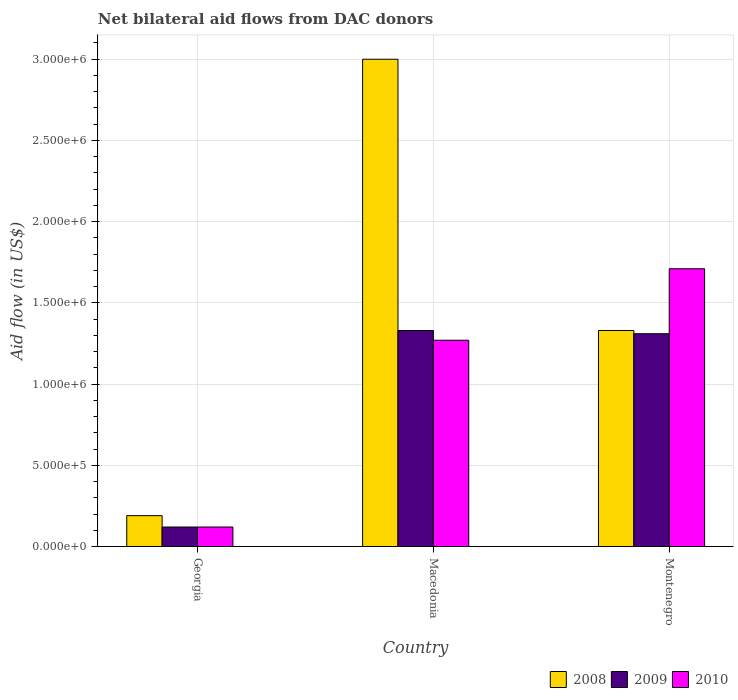How many bars are there on the 1st tick from the left?
Keep it short and to the point. 3. What is the label of the 3rd group of bars from the left?
Offer a terse response. Montenegro. In how many cases, is the number of bars for a given country not equal to the number of legend labels?
Your answer should be compact. 0. What is the net bilateral aid flow in 2008 in Montenegro?
Your response must be concise. 1.33e+06. Across all countries, what is the maximum net bilateral aid flow in 2010?
Provide a succinct answer. 1.71e+06. Across all countries, what is the minimum net bilateral aid flow in 2009?
Give a very brief answer. 1.20e+05. In which country was the net bilateral aid flow in 2010 maximum?
Make the answer very short. Montenegro. In which country was the net bilateral aid flow in 2009 minimum?
Provide a short and direct response. Georgia. What is the total net bilateral aid flow in 2010 in the graph?
Make the answer very short. 3.10e+06. What is the difference between the net bilateral aid flow in 2008 in Macedonia and that in Montenegro?
Offer a very short reply. 1.67e+06. What is the difference between the net bilateral aid flow in 2008 in Georgia and the net bilateral aid flow in 2010 in Montenegro?
Provide a short and direct response. -1.52e+06. What is the average net bilateral aid flow in 2008 per country?
Ensure brevity in your answer.  1.51e+06. In how many countries, is the net bilateral aid flow in 2010 greater than 2100000 US$?
Your answer should be very brief. 0. What is the ratio of the net bilateral aid flow in 2010 in Georgia to that in Montenegro?
Provide a short and direct response. 0.07. Is the difference between the net bilateral aid flow in 2009 in Georgia and Macedonia greater than the difference between the net bilateral aid flow in 2008 in Georgia and Macedonia?
Your response must be concise. Yes. What is the difference between the highest and the lowest net bilateral aid flow in 2008?
Your answer should be very brief. 2.81e+06. Is the sum of the net bilateral aid flow in 2010 in Georgia and Macedonia greater than the maximum net bilateral aid flow in 2008 across all countries?
Your answer should be very brief. No. What is the difference between two consecutive major ticks on the Y-axis?
Provide a short and direct response. 5.00e+05. Are the values on the major ticks of Y-axis written in scientific E-notation?
Offer a very short reply. Yes. How many legend labels are there?
Give a very brief answer. 3. What is the title of the graph?
Ensure brevity in your answer.  Net bilateral aid flows from DAC donors. What is the label or title of the X-axis?
Offer a very short reply. Country. What is the label or title of the Y-axis?
Your response must be concise. Aid flow (in US$). What is the Aid flow (in US$) of 2009 in Macedonia?
Provide a succinct answer. 1.33e+06. What is the Aid flow (in US$) in 2010 in Macedonia?
Give a very brief answer. 1.27e+06. What is the Aid flow (in US$) of 2008 in Montenegro?
Make the answer very short. 1.33e+06. What is the Aid flow (in US$) of 2009 in Montenegro?
Make the answer very short. 1.31e+06. What is the Aid flow (in US$) in 2010 in Montenegro?
Offer a terse response. 1.71e+06. Across all countries, what is the maximum Aid flow (in US$) in 2008?
Your answer should be compact. 3.00e+06. Across all countries, what is the maximum Aid flow (in US$) of 2009?
Keep it short and to the point. 1.33e+06. Across all countries, what is the maximum Aid flow (in US$) in 2010?
Keep it short and to the point. 1.71e+06. Across all countries, what is the minimum Aid flow (in US$) of 2010?
Offer a very short reply. 1.20e+05. What is the total Aid flow (in US$) of 2008 in the graph?
Your answer should be compact. 4.52e+06. What is the total Aid flow (in US$) in 2009 in the graph?
Keep it short and to the point. 2.76e+06. What is the total Aid flow (in US$) of 2010 in the graph?
Your answer should be compact. 3.10e+06. What is the difference between the Aid flow (in US$) of 2008 in Georgia and that in Macedonia?
Your answer should be compact. -2.81e+06. What is the difference between the Aid flow (in US$) of 2009 in Georgia and that in Macedonia?
Offer a terse response. -1.21e+06. What is the difference between the Aid flow (in US$) in 2010 in Georgia and that in Macedonia?
Provide a short and direct response. -1.15e+06. What is the difference between the Aid flow (in US$) in 2008 in Georgia and that in Montenegro?
Your response must be concise. -1.14e+06. What is the difference between the Aid flow (in US$) of 2009 in Georgia and that in Montenegro?
Your answer should be compact. -1.19e+06. What is the difference between the Aid flow (in US$) in 2010 in Georgia and that in Montenegro?
Provide a succinct answer. -1.59e+06. What is the difference between the Aid flow (in US$) of 2008 in Macedonia and that in Montenegro?
Your response must be concise. 1.67e+06. What is the difference between the Aid flow (in US$) of 2010 in Macedonia and that in Montenegro?
Give a very brief answer. -4.40e+05. What is the difference between the Aid flow (in US$) of 2008 in Georgia and the Aid flow (in US$) of 2009 in Macedonia?
Give a very brief answer. -1.14e+06. What is the difference between the Aid flow (in US$) of 2008 in Georgia and the Aid flow (in US$) of 2010 in Macedonia?
Your response must be concise. -1.08e+06. What is the difference between the Aid flow (in US$) in 2009 in Georgia and the Aid flow (in US$) in 2010 in Macedonia?
Ensure brevity in your answer.  -1.15e+06. What is the difference between the Aid flow (in US$) of 2008 in Georgia and the Aid flow (in US$) of 2009 in Montenegro?
Provide a short and direct response. -1.12e+06. What is the difference between the Aid flow (in US$) in 2008 in Georgia and the Aid flow (in US$) in 2010 in Montenegro?
Offer a very short reply. -1.52e+06. What is the difference between the Aid flow (in US$) of 2009 in Georgia and the Aid flow (in US$) of 2010 in Montenegro?
Offer a very short reply. -1.59e+06. What is the difference between the Aid flow (in US$) of 2008 in Macedonia and the Aid flow (in US$) of 2009 in Montenegro?
Your response must be concise. 1.69e+06. What is the difference between the Aid flow (in US$) of 2008 in Macedonia and the Aid flow (in US$) of 2010 in Montenegro?
Keep it short and to the point. 1.29e+06. What is the difference between the Aid flow (in US$) in 2009 in Macedonia and the Aid flow (in US$) in 2010 in Montenegro?
Offer a very short reply. -3.80e+05. What is the average Aid flow (in US$) in 2008 per country?
Give a very brief answer. 1.51e+06. What is the average Aid flow (in US$) of 2009 per country?
Offer a very short reply. 9.20e+05. What is the average Aid flow (in US$) in 2010 per country?
Provide a succinct answer. 1.03e+06. What is the difference between the Aid flow (in US$) of 2009 and Aid flow (in US$) of 2010 in Georgia?
Provide a succinct answer. 0. What is the difference between the Aid flow (in US$) of 2008 and Aid flow (in US$) of 2009 in Macedonia?
Keep it short and to the point. 1.67e+06. What is the difference between the Aid flow (in US$) of 2008 and Aid flow (in US$) of 2010 in Macedonia?
Ensure brevity in your answer.  1.73e+06. What is the difference between the Aid flow (in US$) in 2008 and Aid flow (in US$) in 2010 in Montenegro?
Ensure brevity in your answer.  -3.80e+05. What is the difference between the Aid flow (in US$) of 2009 and Aid flow (in US$) of 2010 in Montenegro?
Ensure brevity in your answer.  -4.00e+05. What is the ratio of the Aid flow (in US$) of 2008 in Georgia to that in Macedonia?
Offer a very short reply. 0.06. What is the ratio of the Aid flow (in US$) in 2009 in Georgia to that in Macedonia?
Make the answer very short. 0.09. What is the ratio of the Aid flow (in US$) of 2010 in Georgia to that in Macedonia?
Keep it short and to the point. 0.09. What is the ratio of the Aid flow (in US$) of 2008 in Georgia to that in Montenegro?
Give a very brief answer. 0.14. What is the ratio of the Aid flow (in US$) of 2009 in Georgia to that in Montenegro?
Offer a terse response. 0.09. What is the ratio of the Aid flow (in US$) in 2010 in Georgia to that in Montenegro?
Provide a succinct answer. 0.07. What is the ratio of the Aid flow (in US$) of 2008 in Macedonia to that in Montenegro?
Keep it short and to the point. 2.26. What is the ratio of the Aid flow (in US$) in 2009 in Macedonia to that in Montenegro?
Ensure brevity in your answer.  1.02. What is the ratio of the Aid flow (in US$) of 2010 in Macedonia to that in Montenegro?
Provide a succinct answer. 0.74. What is the difference between the highest and the second highest Aid flow (in US$) of 2008?
Keep it short and to the point. 1.67e+06. What is the difference between the highest and the second highest Aid flow (in US$) of 2010?
Offer a terse response. 4.40e+05. What is the difference between the highest and the lowest Aid flow (in US$) of 2008?
Provide a short and direct response. 2.81e+06. What is the difference between the highest and the lowest Aid flow (in US$) in 2009?
Make the answer very short. 1.21e+06. What is the difference between the highest and the lowest Aid flow (in US$) in 2010?
Offer a terse response. 1.59e+06. 